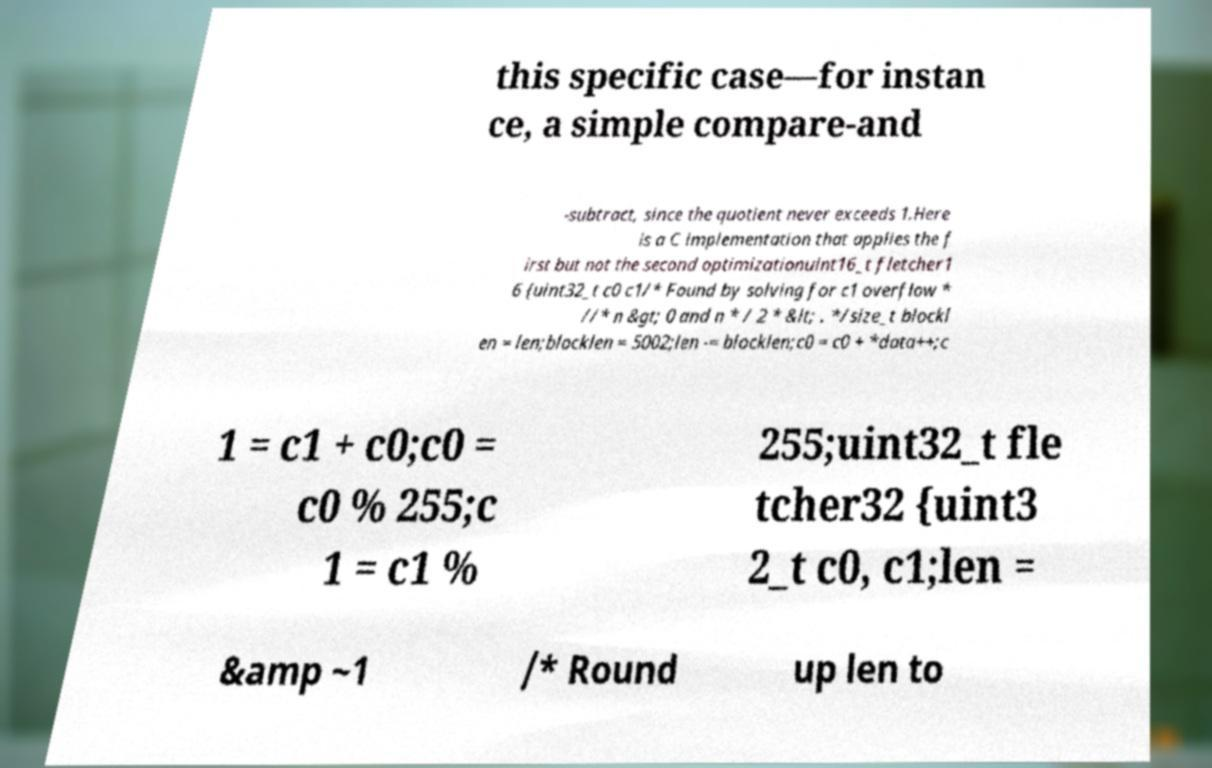Could you extract and type out the text from this image? this specific case—for instan ce, a simple compare-and -subtract, since the quotient never exceeds 1.Here is a C implementation that applies the f irst but not the second optimizationuint16_t fletcher1 6 {uint32_t c0 c1/* Found by solving for c1 overflow * //* n &gt; 0 and n * / 2 * &lt; . */size_t blockl en = len;blocklen = 5002;len -= blocklen;c0 = c0 + *data++;c 1 = c1 + c0;c0 = c0 % 255;c 1 = c1 % 255;uint32_t fle tcher32 {uint3 2_t c0, c1;len = &amp ~1 /* Round up len to 